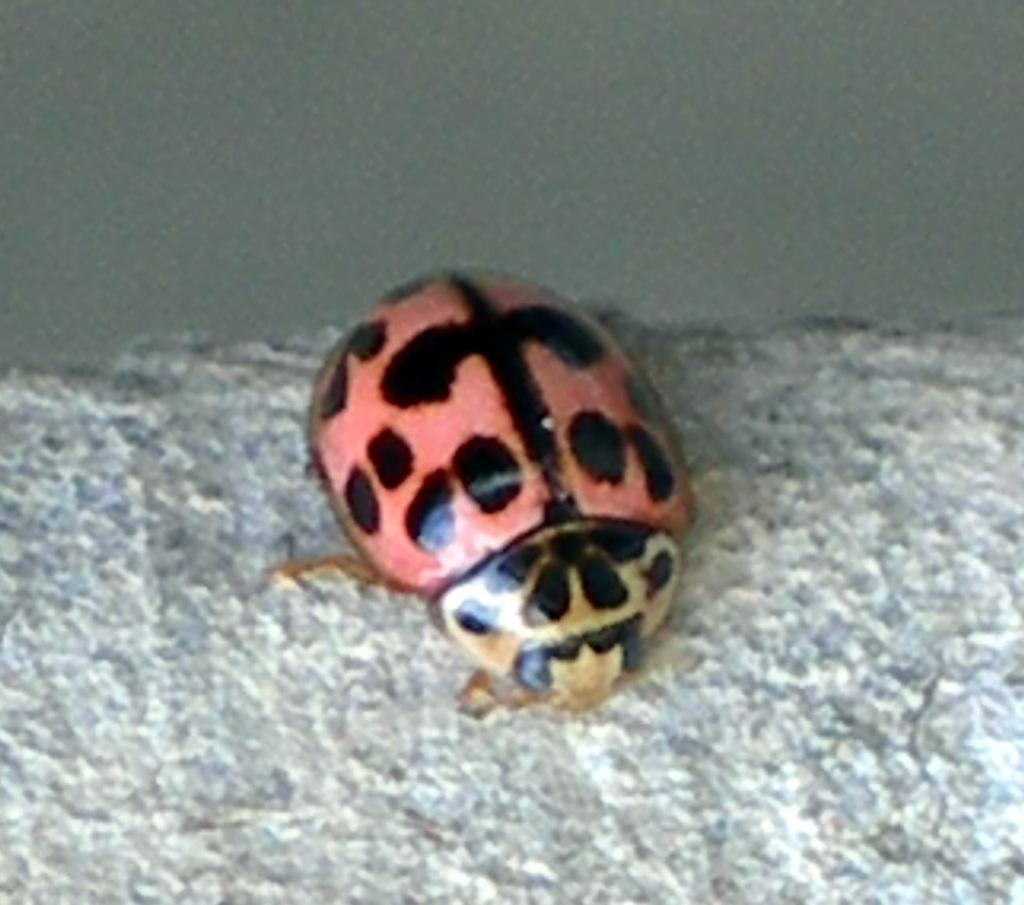What type of creature is in the image? There is an insect in the image. Can you describe the insect's appearance? The insect resembles a ladybird beetle. Where is the insect located in the image? The insect is on the surface. What attempt does the machine make in the image? There is no machine present in the image, so no attempt can be observed. 